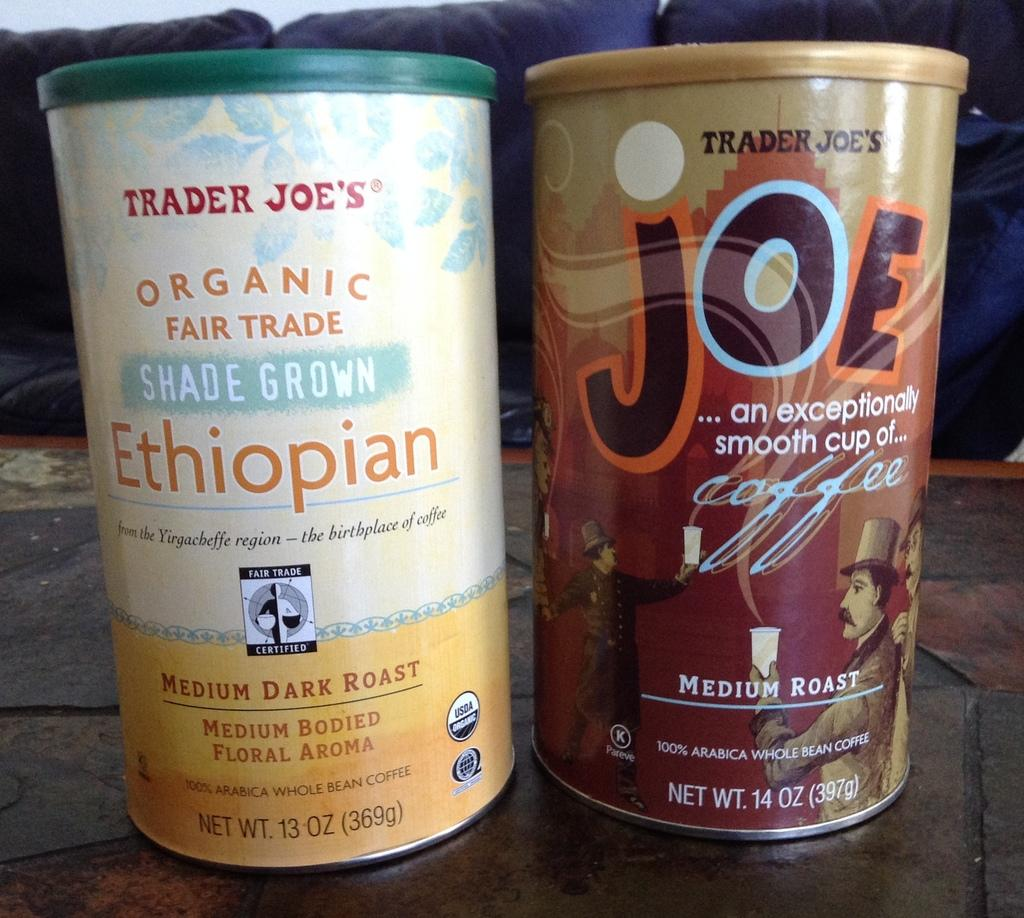<image>
Render a clear and concise summary of the photo. Two different kinds of coffee are offered by the supermarket chain Trader Joe's. 